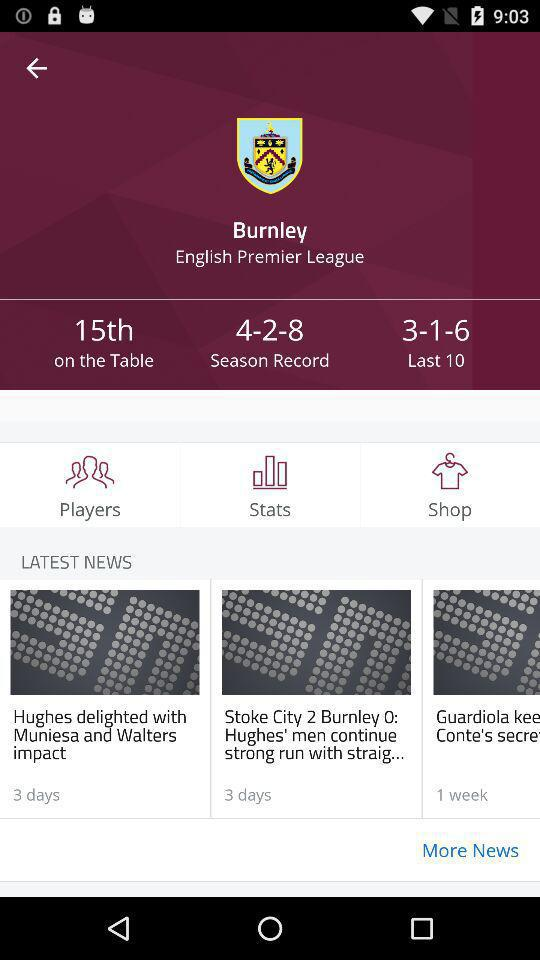What are the latest news? The news are "Hughes delighted with Muniesa and Walters impact", "Stoke City 2 Burnley 0: Hughes's men continue strong run with straig...", and "Guardiola kee Conte's secre". 